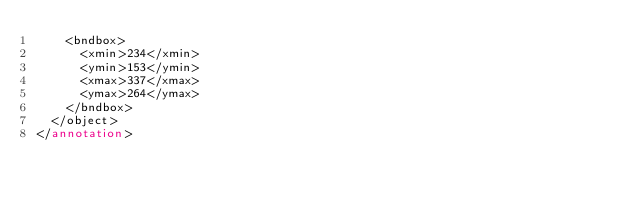<code> <loc_0><loc_0><loc_500><loc_500><_XML_>		<bndbox>
			<xmin>234</xmin>
			<ymin>153</ymin>
			<xmax>337</xmax>
			<ymax>264</ymax>
		</bndbox>
	</object>
</annotation>
</code> 